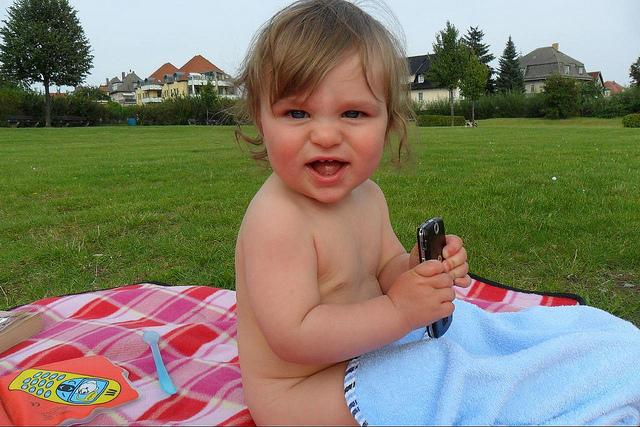What fairly important item is missing from this child? clothes 